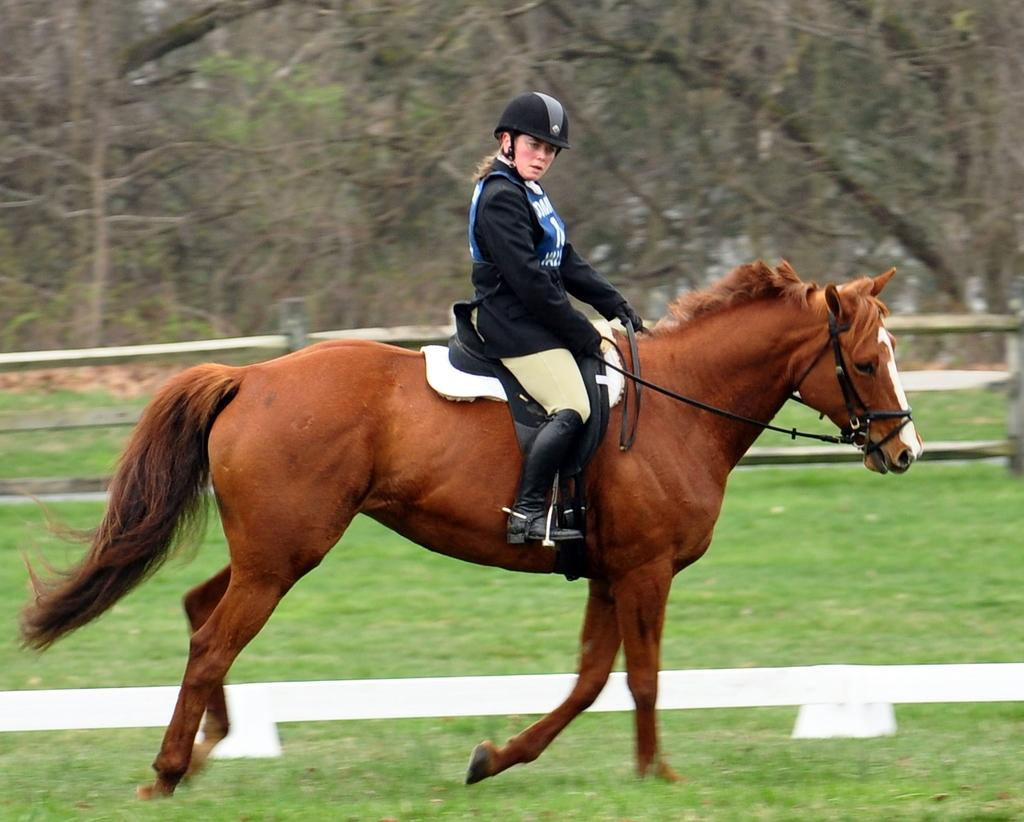What is the person in the image doing? The person is riding a horse in the image. What color is the horse? The horse is brown. What can be seen near the person and horse? There is a railing in the image. What is visible in the background of the image? There are trees in the background of the image. What is the level of quietness in the image? The level of quietness cannot be determined from the image, as it does not convey any auditory information. 